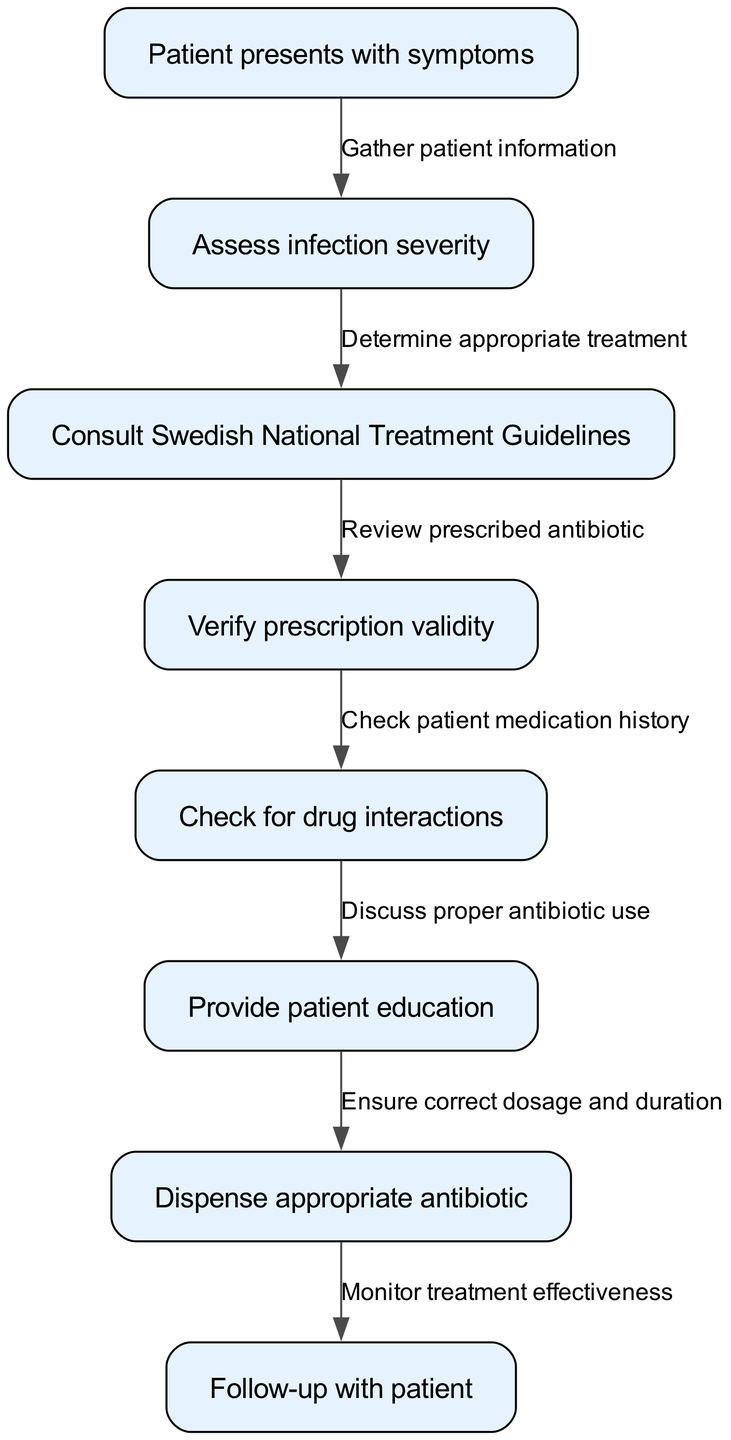What is the first step in the diagram? The first step is represented by the node with ID "1", which states "Patient presents with symptoms". This is where the clinical pathway begins.
Answer: Patient presents with symptoms How many nodes are there in the diagram? By counting the entries in the "nodes" list provided in the data, there are 8 distinct nodes detailing the various steps in the pathway.
Answer: 8 What action follows assessing infection severity? The diagram shows that after "Assess infection severity", the next step is to "Consult Swedish National Treatment Guidelines". This follows the connection from node "2" to node "3".
Answer: Consult Swedish National Treatment Guidelines What is the edge connecting "Dispense appropriate antibiotic" to "Follow-up with patient"? The edge connecting these nodes is labeled "Monitor treatment effectiveness", as indicated in the data transitions from node "7" to node "8".
Answer: Monitor treatment effectiveness What should be checked before providing patient education? According to the diagram, before providing patient education, one must check for drug interactions, evident by the flow from node "5" to node "6".
Answer: Check for drug interactions Which node involves verifying prescription validity? Node "4" explicitly states "Verify prescription validity", indicating this step within the pathway.
Answer: Verify prescription validity How does one determine the appropriate treatment in this pathway? The pathway shows that appropriate treatment is determined by consulting the Swedish National Treatment Guidelines, which is the action following assessing infection severity. This is derived from the transition from node "2" to node "3".
Answer: Consult Swedish National Treatment Guidelines What is the purpose of the step that describes patient education? The purpose, described in node "6", is to discuss proper antibiotic use, which is essential for both patient understanding and adherence to the prescribed treatment.
Answer: Discuss proper antibiotic use 